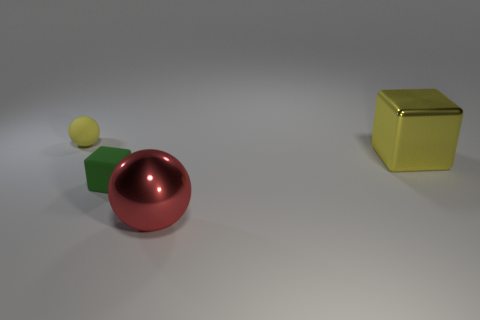What number of objects are cyan blocks or large metallic things that are right of the large ball?
Provide a succinct answer. 1. How many other objects are the same material as the green object?
Offer a very short reply. 1. How many things are either gray objects or red shiny objects?
Ensure brevity in your answer.  1. Is the number of big yellow metal blocks behind the small yellow sphere greater than the number of small green things on the right side of the large yellow block?
Keep it short and to the point. No. There is a metallic thing behind the rubber block; is it the same color as the ball behind the red shiny thing?
Your response must be concise. Yes. There is a ball in front of the sphere that is behind the large object behind the tiny green object; what size is it?
Ensure brevity in your answer.  Large. There is another small object that is the same shape as the yellow shiny object; what color is it?
Ensure brevity in your answer.  Green. Is the number of large yellow metal objects in front of the green block greater than the number of yellow cubes?
Your answer should be very brief. No. Is the shape of the red object the same as the small object in front of the small ball?
Make the answer very short. No. Are there any other things that are the same size as the red metal sphere?
Make the answer very short. Yes. 